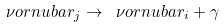Convert formula to latex. <formula><loc_0><loc_0><loc_500><loc_500>\nu o r n u b a r _ { j } \to \ \nu o r n u b a r _ { i } + \gamma \</formula> 